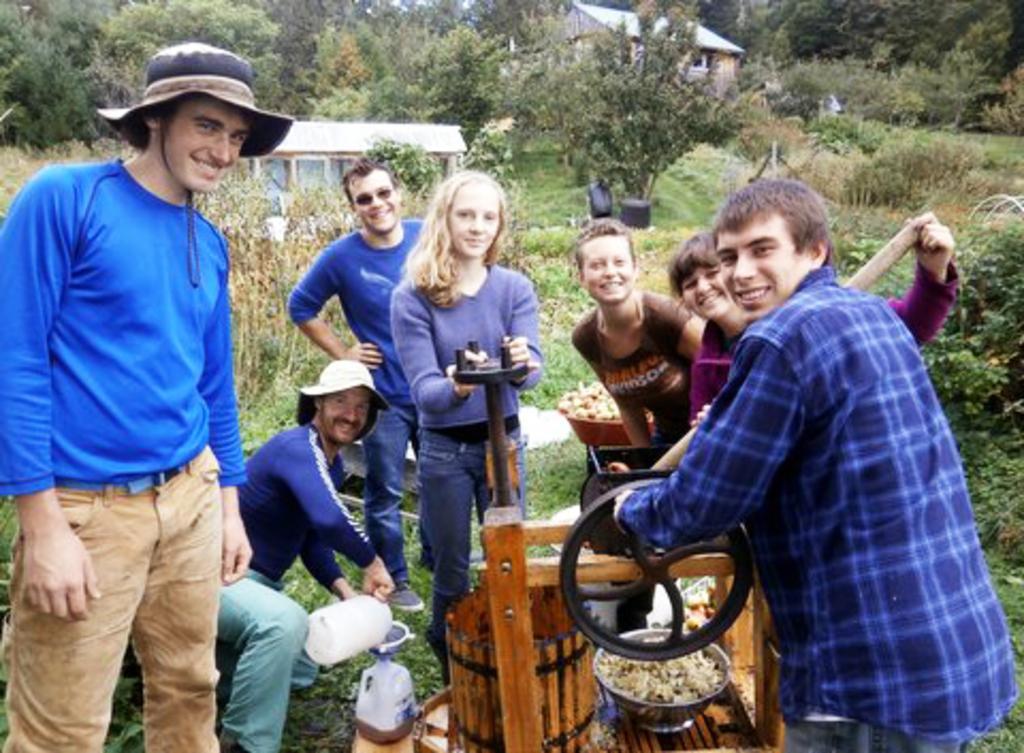Describe this image in one or two sentences. In the foreground of this image, there are persons standing near a machine and having smile on their faces and in the background, there are houses, trees, plants and the grass. 